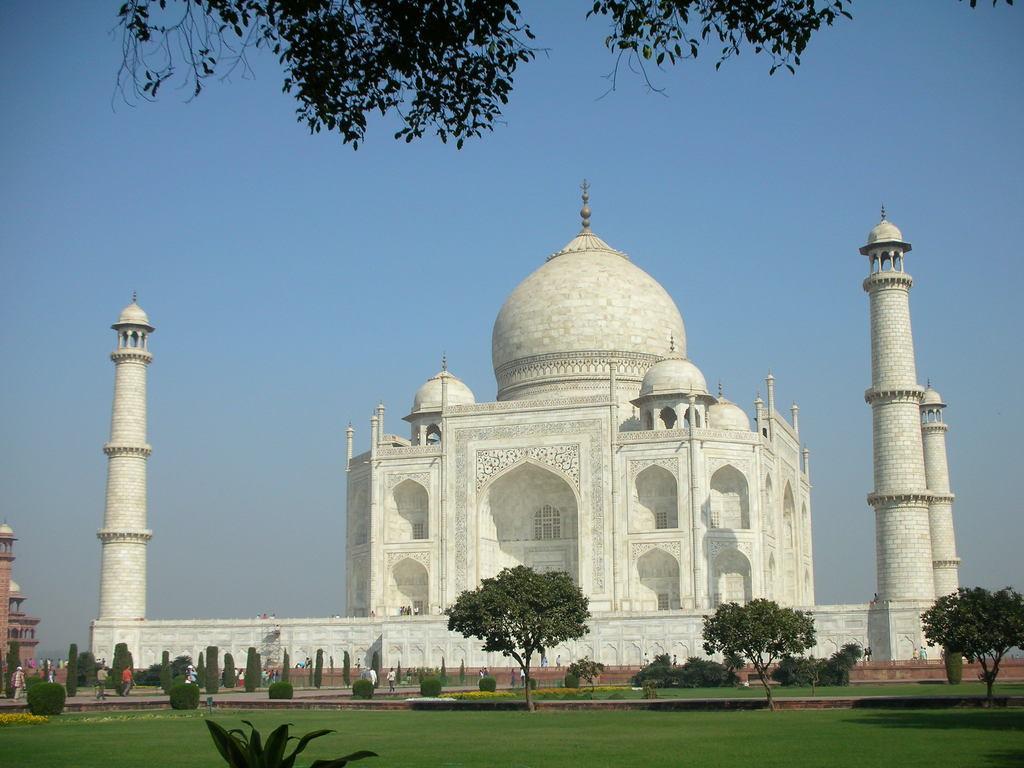Please provide a concise description of this image. This is a Taj Mahal. Here we can see grass, plants, trees, and few persons. In the background there is sky. 